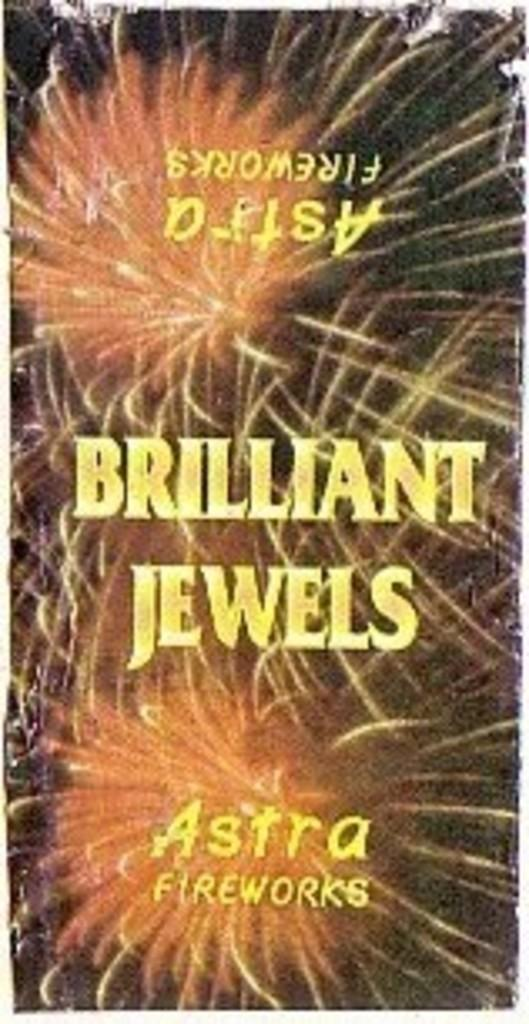<image>
Share a concise interpretation of the image provided. A pamphlet has fireworks on it and says Brilliant Jewels. 